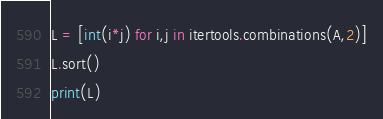Convert code to text. <code><loc_0><loc_0><loc_500><loc_500><_Python_>L = [int(i*j) for i,j in itertools.combinations(A,2)]
L.sort()
print(L)</code> 